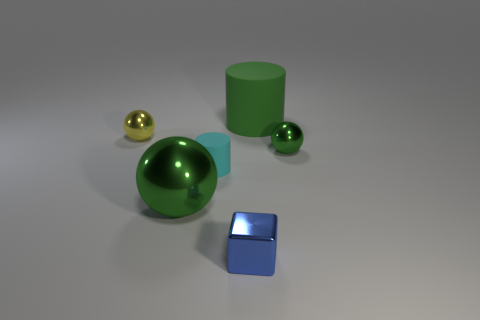What is the material of the tiny object that is the same shape as the large rubber thing?
Make the answer very short. Rubber. The rubber thing that is right of the tiny metallic object in front of the tiny metallic sphere that is in front of the small yellow sphere is what shape?
Your answer should be compact. Cylinder. There is a big thing that is the same color as the big rubber cylinder; what is it made of?
Your answer should be very brief. Metal. How many small objects are the same shape as the large green rubber thing?
Give a very brief answer. 1. There is a small metal sphere right of the green rubber cylinder; does it have the same color as the cylinder that is on the right side of the tiny blue shiny thing?
Your answer should be compact. Yes. There is a thing that is the same size as the green matte cylinder; what is its material?
Make the answer very short. Metal. Is there a green rubber cylinder that has the same size as the green matte thing?
Your answer should be very brief. No. Is the number of big metal objects behind the small yellow metal sphere less than the number of brown balls?
Give a very brief answer. No. Is the number of big green shiny balls right of the blue metallic thing less than the number of large rubber things that are on the right side of the large metallic sphere?
Offer a very short reply. Yes. How many balls are either big green objects or blue objects?
Your answer should be very brief. 1. 